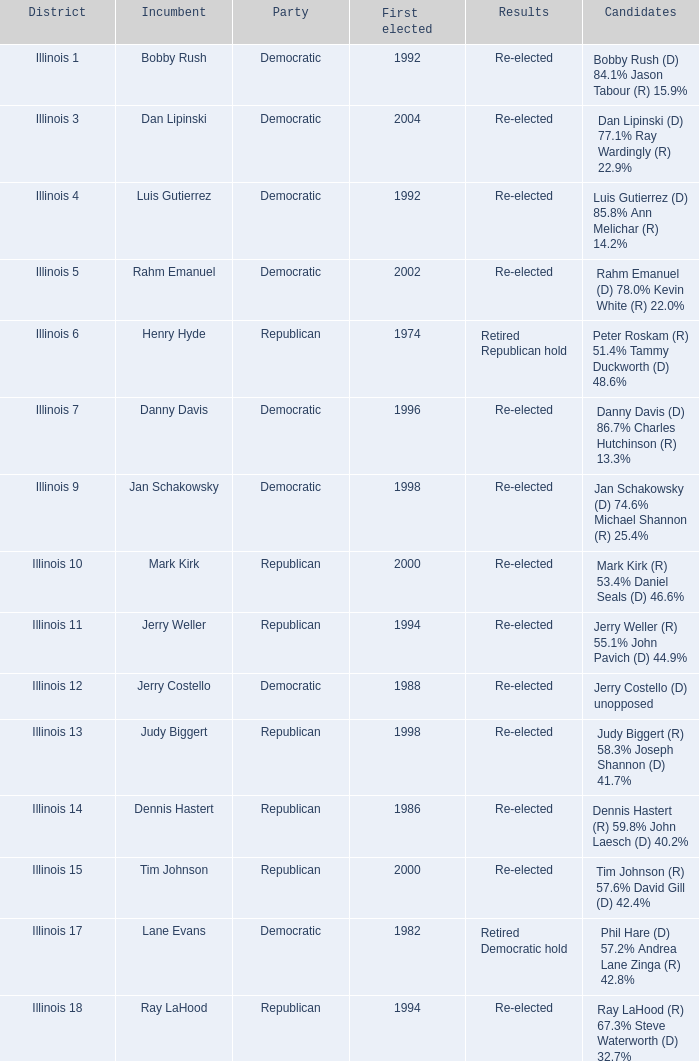What is the zone where the inaugural election happened in 1986? Illinois 14. 